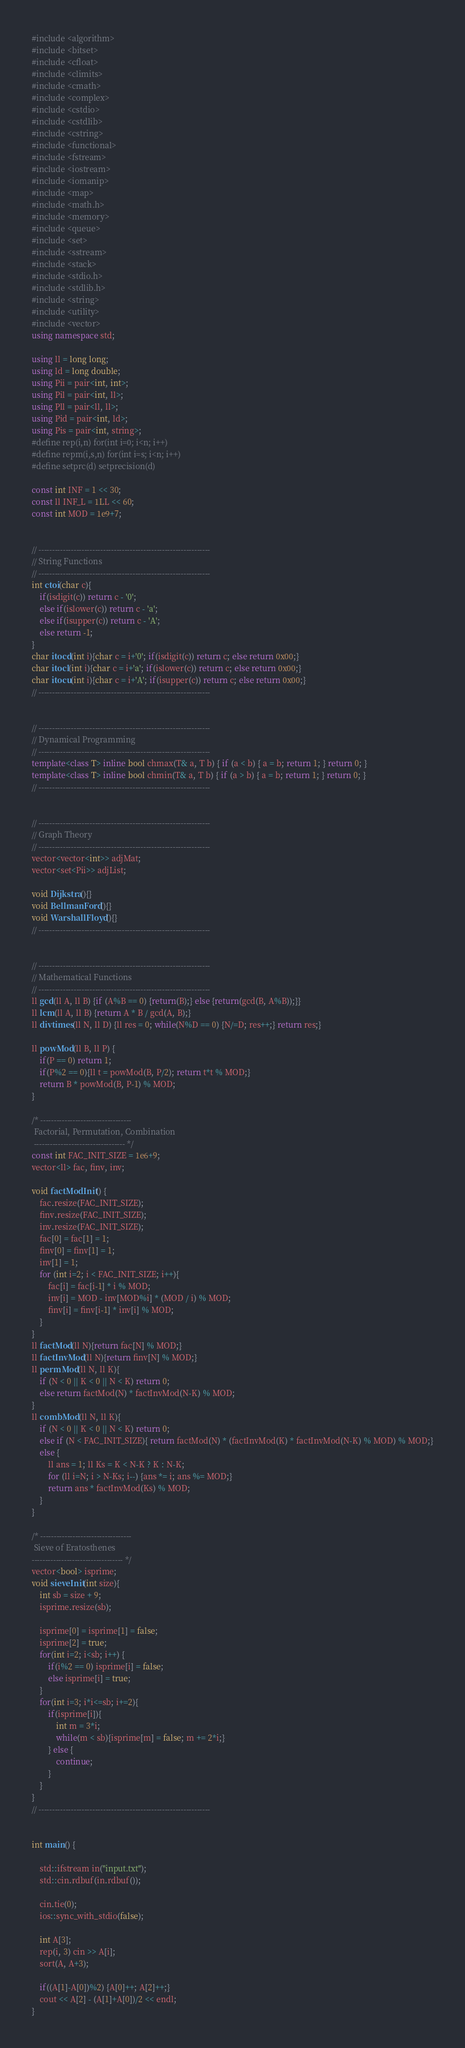Convert code to text. <code><loc_0><loc_0><loc_500><loc_500><_C++_>#include <algorithm>
#include <bitset>
#include <cfloat>
#include <climits>
#include <cmath>
#include <complex>
#include <cstdio>
#include <cstdlib>
#include <cstring>
#include <functional>
#include <fstream>
#include <iostream>
#include <iomanip>
#include <map>
#include <math.h>
#include <memory>
#include <queue>
#include <set>
#include <sstream>
#include <stack>
#include <stdio.h>
#include <stdlib.h>
#include <string>
#include <utility>
#include <vector>
using namespace std;

using ll = long long;
using ld = long double;
using Pii = pair<int, int>;
using Pil = pair<int, ll>;
using Pll = pair<ll, ll>;
using Pid = pair<int, ld>;
using Pis = pair<int, string>;
#define rep(i,n) for(int i=0; i<n; i++)
#define repm(i,s,n) for(int i=s; i<n; i++)
#define setprc(d) setprecision(d)

const int INF = 1 << 30;
const ll INF_L = 1LL << 60;
const int MOD = 1e9+7;


// ----------------------------------------------------------------
// String Functions
// ----------------------------------------------------------------
int ctoi(char c){
    if(isdigit(c)) return c - '0';
    else if(islower(c)) return c - 'a';
    else if(isupper(c)) return c - 'A';
    else return -1;
}
char itocd(int i){char c = i+'0'; if(isdigit(c)) return c; else return 0x00;}
char itocl(int i){char c = i+'a'; if(islower(c)) return c; else return 0x00;}
char itocu(int i){char c = i+'A'; if(isupper(c)) return c; else return 0x00;}
// ----------------------------------------------------------------


// ----------------------------------------------------------------
// Dynamical Programming
// ----------------------------------------------------------------
template<class T> inline bool chmax(T& a, T b) { if (a < b) { a = b; return 1; } return 0; }
template<class T> inline bool chmin(T& a, T b) { if (a > b) { a = b; return 1; } return 0; }
// ----------------------------------------------------------------


// ----------------------------------------------------------------
// Graph Theory
// ----------------------------------------------------------------
vector<vector<int>> adjMat;
vector<set<Pii>> adjList;

void Dijkstra(){}
void BellmanFord(){}
void WarshallFloyd(){}
// ----------------------------------------------------------------


// ----------------------------------------------------------------
// Mathematical Functions
// ----------------------------------------------------------------
ll gcd(ll A, ll B) {if (A%B == 0) {return(B);} else {return(gcd(B, A%B));}}
ll lcm(ll A, ll B) {return A * B / gcd(A, B);}
ll divtimes(ll N, ll D) {ll res = 0; while(N%D == 0) {N/=D; res++;} return res;}

ll powMod(ll B, ll P) {
    if(P == 0) return 1;
    if(P%2 == 0){ll t = powMod(B, P/2); return t*t % MOD;}
    return B * powMod(B, P-1) % MOD;
}

/* ----------------------------------
 Factorial, Permutation, Combination
 ---------------------------------- */
const int FAC_INIT_SIZE = 1e6+9;
vector<ll> fac, finv, inv;

void factModInit() {
    fac.resize(FAC_INIT_SIZE);
    finv.resize(FAC_INIT_SIZE);
    inv.resize(FAC_INIT_SIZE);
    fac[0] = fac[1] = 1;
    finv[0] = finv[1] = 1;
    inv[1] = 1;
    for (int i=2; i < FAC_INIT_SIZE; i++){
        fac[i] = fac[i-1] * i % MOD;
        inv[i] = MOD - inv[MOD%i] * (MOD / i) % MOD;
        finv[i] = finv[i-1] * inv[i] % MOD;
    }
}
ll factMod(ll N){return fac[N] % MOD;}
ll factInvMod(ll N){return finv[N] % MOD;}
ll permMod(ll N, ll K){
    if (N < 0 || K < 0 || N < K) return 0;
    else return factMod(N) * factInvMod(N-K) % MOD;
}
ll combMod(ll N, ll K){
    if (N < 0 || K < 0 || N < K) return 0;
    else if (N < FAC_INIT_SIZE){ return factMod(N) * (factInvMod(K) * factInvMod(N-K) % MOD) % MOD;}
    else {
        ll ans = 1; ll Ks = K < N-K ? K : N-K;
        for (ll i=N; i > N-Ks; i--) {ans *= i; ans %= MOD;}
        return ans * factInvMod(Ks) % MOD;
    }
}

/* ----------------------------------
 Sieve of Eratosthenes
---------------------------------- */
vector<bool> isprime;
void sieveInit(int size){
    int sb = size + 9;
    isprime.resize(sb);
    
    isprime[0] = isprime[1] = false;
    isprime[2] = true;
    for(int i=2; i<sb; i++) {
        if(i%2 == 0) isprime[i] = false;
        else isprime[i] = true;
    }
    for(int i=3; i*i<=sb; i+=2){
        if(isprime[i]){
            int m = 3*i;
            while(m < sb){isprime[m] = false; m += 2*i;}
        } else {
            continue;
        }
    }
}
// ----------------------------------------------------------------


int main() {
    
    std::ifstream in("input.txt");
    std::cin.rdbuf(in.rdbuf());
    
    cin.tie(0);
    ios::sync_with_stdio(false);
 
    int A[3];
    rep(i, 3) cin >> A[i];
    sort(A, A+3);
    
    if((A[1]-A[0])%2) {A[0]++; A[2]++;}
    cout << A[2] - (A[1]+A[0])/2 << endl;
}
</code> 